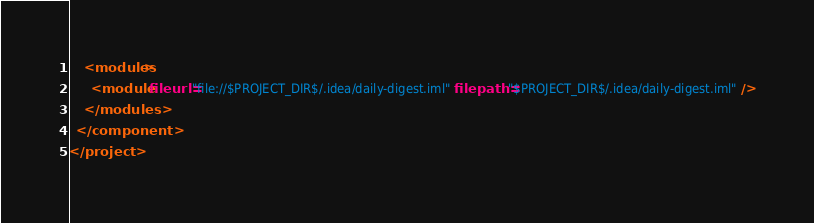<code> <loc_0><loc_0><loc_500><loc_500><_XML_>    <modules>
      <module fileurl="file://$PROJECT_DIR$/.idea/daily-digest.iml" filepath="$PROJECT_DIR$/.idea/daily-digest.iml" />
    </modules>
  </component>
</project></code> 